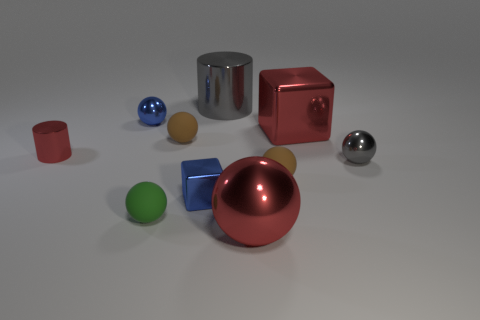There is a red metallic sphere; is its size the same as the blue shiny object that is on the left side of the green ball?
Your answer should be compact. No. Are there any metallic things that have the same color as the large metal cube?
Provide a succinct answer. Yes. Is there a tiny gray thing of the same shape as the small red object?
Your response must be concise. No. The big thing that is in front of the big gray thing and to the left of the big red metal block has what shape?
Offer a terse response. Sphere. What number of small blue balls are the same material as the tiny cube?
Make the answer very short. 1. Are there fewer tiny gray metal spheres on the left side of the red ball than small red rubber cylinders?
Make the answer very short. No. Are there any big red shiny balls that are on the left side of the shiny sphere to the left of the blue cube?
Keep it short and to the point. No. Is there any other thing that is the same shape as the green thing?
Make the answer very short. Yes. Is the green sphere the same size as the red shiny cylinder?
Give a very brief answer. Yes. What material is the small brown sphere that is in front of the shiny cylinder left of the big object that is behind the big red shiny block made of?
Give a very brief answer. Rubber. 